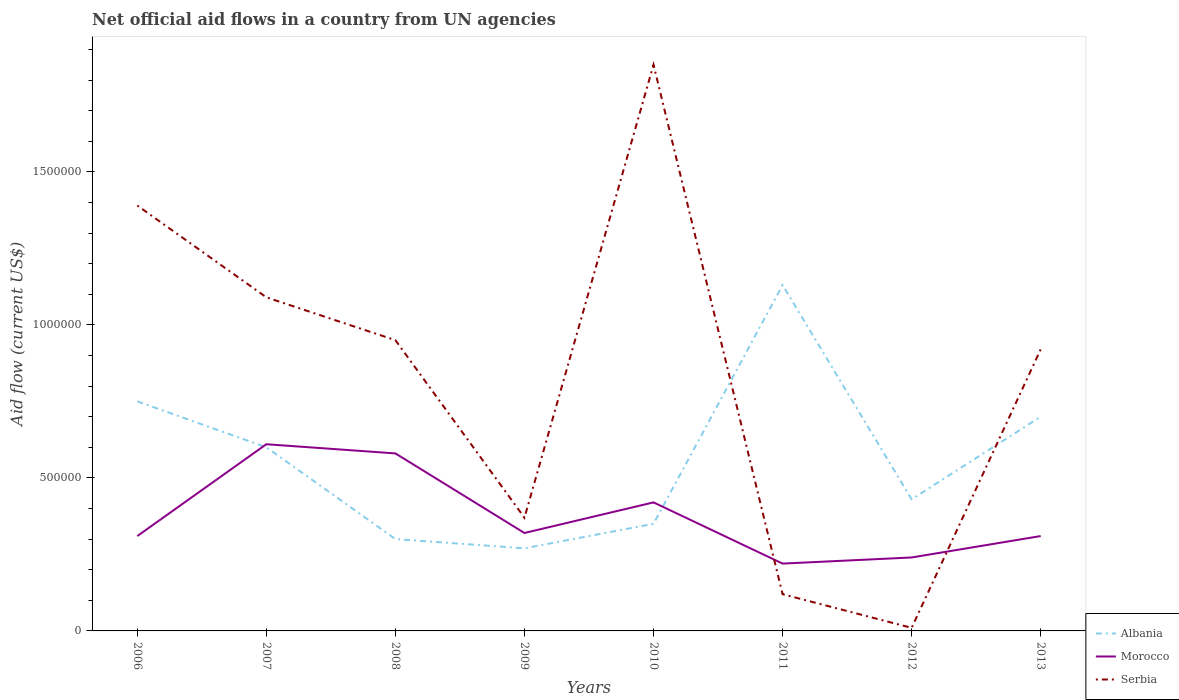How many different coloured lines are there?
Keep it short and to the point. 3. Across all years, what is the maximum net official aid flow in Serbia?
Provide a succinct answer. 10000. In which year was the net official aid flow in Morocco maximum?
Offer a terse response. 2011. What is the total net official aid flow in Albania in the graph?
Give a very brief answer. -4.00e+05. What is the difference between the highest and the second highest net official aid flow in Serbia?
Offer a terse response. 1.84e+06. Are the values on the major ticks of Y-axis written in scientific E-notation?
Provide a succinct answer. No. Does the graph contain any zero values?
Your response must be concise. No. Does the graph contain grids?
Ensure brevity in your answer.  No. How are the legend labels stacked?
Offer a very short reply. Vertical. What is the title of the graph?
Your response must be concise. Net official aid flows in a country from UN agencies. What is the label or title of the X-axis?
Your answer should be compact. Years. What is the Aid flow (current US$) in Albania in 2006?
Offer a very short reply. 7.50e+05. What is the Aid flow (current US$) in Serbia in 2006?
Ensure brevity in your answer.  1.39e+06. What is the Aid flow (current US$) in Serbia in 2007?
Your answer should be very brief. 1.09e+06. What is the Aid flow (current US$) in Morocco in 2008?
Offer a terse response. 5.80e+05. What is the Aid flow (current US$) in Serbia in 2008?
Give a very brief answer. 9.50e+05. What is the Aid flow (current US$) in Morocco in 2009?
Provide a succinct answer. 3.20e+05. What is the Aid flow (current US$) in Serbia in 2009?
Give a very brief answer. 3.70e+05. What is the Aid flow (current US$) in Morocco in 2010?
Offer a terse response. 4.20e+05. What is the Aid flow (current US$) of Serbia in 2010?
Your answer should be very brief. 1.85e+06. What is the Aid flow (current US$) in Albania in 2011?
Offer a terse response. 1.13e+06. What is the Aid flow (current US$) of Morocco in 2011?
Ensure brevity in your answer.  2.20e+05. What is the Aid flow (current US$) of Albania in 2012?
Ensure brevity in your answer.  4.30e+05. What is the Aid flow (current US$) in Morocco in 2012?
Your answer should be very brief. 2.40e+05. What is the Aid flow (current US$) of Morocco in 2013?
Ensure brevity in your answer.  3.10e+05. What is the Aid flow (current US$) of Serbia in 2013?
Keep it short and to the point. 9.20e+05. Across all years, what is the maximum Aid flow (current US$) of Albania?
Your answer should be compact. 1.13e+06. Across all years, what is the maximum Aid flow (current US$) of Morocco?
Keep it short and to the point. 6.10e+05. Across all years, what is the maximum Aid flow (current US$) in Serbia?
Keep it short and to the point. 1.85e+06. Across all years, what is the minimum Aid flow (current US$) in Albania?
Your answer should be compact. 2.70e+05. Across all years, what is the minimum Aid flow (current US$) in Morocco?
Provide a succinct answer. 2.20e+05. Across all years, what is the minimum Aid flow (current US$) in Serbia?
Your answer should be compact. 10000. What is the total Aid flow (current US$) in Albania in the graph?
Your response must be concise. 4.53e+06. What is the total Aid flow (current US$) of Morocco in the graph?
Your response must be concise. 3.01e+06. What is the total Aid flow (current US$) in Serbia in the graph?
Your answer should be compact. 6.70e+06. What is the difference between the Aid flow (current US$) of Serbia in 2006 and that in 2007?
Your answer should be compact. 3.00e+05. What is the difference between the Aid flow (current US$) in Morocco in 2006 and that in 2008?
Offer a very short reply. -2.70e+05. What is the difference between the Aid flow (current US$) of Serbia in 2006 and that in 2008?
Ensure brevity in your answer.  4.40e+05. What is the difference between the Aid flow (current US$) in Serbia in 2006 and that in 2009?
Make the answer very short. 1.02e+06. What is the difference between the Aid flow (current US$) of Albania in 2006 and that in 2010?
Ensure brevity in your answer.  4.00e+05. What is the difference between the Aid flow (current US$) of Morocco in 2006 and that in 2010?
Your answer should be compact. -1.10e+05. What is the difference between the Aid flow (current US$) in Serbia in 2006 and that in 2010?
Your response must be concise. -4.60e+05. What is the difference between the Aid flow (current US$) of Albania in 2006 and that in 2011?
Provide a succinct answer. -3.80e+05. What is the difference between the Aid flow (current US$) of Serbia in 2006 and that in 2011?
Give a very brief answer. 1.27e+06. What is the difference between the Aid flow (current US$) in Serbia in 2006 and that in 2012?
Make the answer very short. 1.38e+06. What is the difference between the Aid flow (current US$) of Morocco in 2006 and that in 2013?
Your response must be concise. 0. What is the difference between the Aid flow (current US$) of Serbia in 2007 and that in 2008?
Offer a very short reply. 1.40e+05. What is the difference between the Aid flow (current US$) of Serbia in 2007 and that in 2009?
Keep it short and to the point. 7.20e+05. What is the difference between the Aid flow (current US$) of Morocco in 2007 and that in 2010?
Give a very brief answer. 1.90e+05. What is the difference between the Aid flow (current US$) in Serbia in 2007 and that in 2010?
Ensure brevity in your answer.  -7.60e+05. What is the difference between the Aid flow (current US$) of Albania in 2007 and that in 2011?
Your response must be concise. -5.30e+05. What is the difference between the Aid flow (current US$) in Morocco in 2007 and that in 2011?
Your answer should be very brief. 3.90e+05. What is the difference between the Aid flow (current US$) in Serbia in 2007 and that in 2011?
Provide a short and direct response. 9.70e+05. What is the difference between the Aid flow (current US$) of Morocco in 2007 and that in 2012?
Your answer should be very brief. 3.70e+05. What is the difference between the Aid flow (current US$) in Serbia in 2007 and that in 2012?
Your response must be concise. 1.08e+06. What is the difference between the Aid flow (current US$) in Albania in 2007 and that in 2013?
Ensure brevity in your answer.  -1.00e+05. What is the difference between the Aid flow (current US$) of Serbia in 2007 and that in 2013?
Offer a terse response. 1.70e+05. What is the difference between the Aid flow (current US$) of Serbia in 2008 and that in 2009?
Your answer should be very brief. 5.80e+05. What is the difference between the Aid flow (current US$) in Morocco in 2008 and that in 2010?
Your response must be concise. 1.60e+05. What is the difference between the Aid flow (current US$) in Serbia in 2008 and that in 2010?
Provide a short and direct response. -9.00e+05. What is the difference between the Aid flow (current US$) in Albania in 2008 and that in 2011?
Provide a succinct answer. -8.30e+05. What is the difference between the Aid flow (current US$) in Serbia in 2008 and that in 2011?
Offer a very short reply. 8.30e+05. What is the difference between the Aid flow (current US$) of Albania in 2008 and that in 2012?
Provide a succinct answer. -1.30e+05. What is the difference between the Aid flow (current US$) in Serbia in 2008 and that in 2012?
Offer a very short reply. 9.40e+05. What is the difference between the Aid flow (current US$) in Albania in 2008 and that in 2013?
Provide a succinct answer. -4.00e+05. What is the difference between the Aid flow (current US$) in Morocco in 2009 and that in 2010?
Provide a short and direct response. -1.00e+05. What is the difference between the Aid flow (current US$) in Serbia in 2009 and that in 2010?
Your answer should be very brief. -1.48e+06. What is the difference between the Aid flow (current US$) in Albania in 2009 and that in 2011?
Ensure brevity in your answer.  -8.60e+05. What is the difference between the Aid flow (current US$) in Albania in 2009 and that in 2012?
Your response must be concise. -1.60e+05. What is the difference between the Aid flow (current US$) of Albania in 2009 and that in 2013?
Ensure brevity in your answer.  -4.30e+05. What is the difference between the Aid flow (current US$) in Morocco in 2009 and that in 2013?
Your answer should be very brief. 10000. What is the difference between the Aid flow (current US$) in Serbia in 2009 and that in 2013?
Offer a very short reply. -5.50e+05. What is the difference between the Aid flow (current US$) in Albania in 2010 and that in 2011?
Make the answer very short. -7.80e+05. What is the difference between the Aid flow (current US$) of Serbia in 2010 and that in 2011?
Provide a short and direct response. 1.73e+06. What is the difference between the Aid flow (current US$) in Albania in 2010 and that in 2012?
Provide a succinct answer. -8.00e+04. What is the difference between the Aid flow (current US$) of Serbia in 2010 and that in 2012?
Ensure brevity in your answer.  1.84e+06. What is the difference between the Aid flow (current US$) in Albania in 2010 and that in 2013?
Offer a terse response. -3.50e+05. What is the difference between the Aid flow (current US$) of Morocco in 2010 and that in 2013?
Make the answer very short. 1.10e+05. What is the difference between the Aid flow (current US$) in Serbia in 2010 and that in 2013?
Your answer should be very brief. 9.30e+05. What is the difference between the Aid flow (current US$) in Albania in 2011 and that in 2013?
Offer a terse response. 4.30e+05. What is the difference between the Aid flow (current US$) in Serbia in 2011 and that in 2013?
Offer a very short reply. -8.00e+05. What is the difference between the Aid flow (current US$) in Albania in 2012 and that in 2013?
Your answer should be very brief. -2.70e+05. What is the difference between the Aid flow (current US$) in Morocco in 2012 and that in 2013?
Offer a very short reply. -7.00e+04. What is the difference between the Aid flow (current US$) in Serbia in 2012 and that in 2013?
Provide a short and direct response. -9.10e+05. What is the difference between the Aid flow (current US$) of Albania in 2006 and the Aid flow (current US$) of Serbia in 2007?
Provide a short and direct response. -3.40e+05. What is the difference between the Aid flow (current US$) of Morocco in 2006 and the Aid flow (current US$) of Serbia in 2007?
Your response must be concise. -7.80e+05. What is the difference between the Aid flow (current US$) of Albania in 2006 and the Aid flow (current US$) of Serbia in 2008?
Your response must be concise. -2.00e+05. What is the difference between the Aid flow (current US$) of Morocco in 2006 and the Aid flow (current US$) of Serbia in 2008?
Make the answer very short. -6.40e+05. What is the difference between the Aid flow (current US$) of Albania in 2006 and the Aid flow (current US$) of Morocco in 2010?
Give a very brief answer. 3.30e+05. What is the difference between the Aid flow (current US$) in Albania in 2006 and the Aid flow (current US$) in Serbia in 2010?
Keep it short and to the point. -1.10e+06. What is the difference between the Aid flow (current US$) in Morocco in 2006 and the Aid flow (current US$) in Serbia in 2010?
Your response must be concise. -1.54e+06. What is the difference between the Aid flow (current US$) in Albania in 2006 and the Aid flow (current US$) in Morocco in 2011?
Your response must be concise. 5.30e+05. What is the difference between the Aid flow (current US$) of Albania in 2006 and the Aid flow (current US$) of Serbia in 2011?
Give a very brief answer. 6.30e+05. What is the difference between the Aid flow (current US$) of Albania in 2006 and the Aid flow (current US$) of Morocco in 2012?
Offer a terse response. 5.10e+05. What is the difference between the Aid flow (current US$) in Albania in 2006 and the Aid flow (current US$) in Serbia in 2012?
Your answer should be compact. 7.40e+05. What is the difference between the Aid flow (current US$) of Albania in 2006 and the Aid flow (current US$) of Serbia in 2013?
Your response must be concise. -1.70e+05. What is the difference between the Aid flow (current US$) of Morocco in 2006 and the Aid flow (current US$) of Serbia in 2013?
Keep it short and to the point. -6.10e+05. What is the difference between the Aid flow (current US$) of Albania in 2007 and the Aid flow (current US$) of Morocco in 2008?
Offer a very short reply. 2.00e+04. What is the difference between the Aid flow (current US$) of Albania in 2007 and the Aid flow (current US$) of Serbia in 2008?
Make the answer very short. -3.50e+05. What is the difference between the Aid flow (current US$) in Albania in 2007 and the Aid flow (current US$) in Morocco in 2009?
Your answer should be very brief. 2.80e+05. What is the difference between the Aid flow (current US$) of Albania in 2007 and the Aid flow (current US$) of Serbia in 2010?
Your response must be concise. -1.25e+06. What is the difference between the Aid flow (current US$) in Morocco in 2007 and the Aid flow (current US$) in Serbia in 2010?
Offer a very short reply. -1.24e+06. What is the difference between the Aid flow (current US$) in Albania in 2007 and the Aid flow (current US$) in Morocco in 2011?
Offer a very short reply. 3.80e+05. What is the difference between the Aid flow (current US$) of Albania in 2007 and the Aid flow (current US$) of Serbia in 2012?
Provide a succinct answer. 5.90e+05. What is the difference between the Aid flow (current US$) of Morocco in 2007 and the Aid flow (current US$) of Serbia in 2012?
Provide a succinct answer. 6.00e+05. What is the difference between the Aid flow (current US$) of Albania in 2007 and the Aid flow (current US$) of Serbia in 2013?
Provide a short and direct response. -3.20e+05. What is the difference between the Aid flow (current US$) of Morocco in 2007 and the Aid flow (current US$) of Serbia in 2013?
Offer a terse response. -3.10e+05. What is the difference between the Aid flow (current US$) in Albania in 2008 and the Aid flow (current US$) in Morocco in 2009?
Your answer should be compact. -2.00e+04. What is the difference between the Aid flow (current US$) in Albania in 2008 and the Aid flow (current US$) in Serbia in 2009?
Your response must be concise. -7.00e+04. What is the difference between the Aid flow (current US$) in Albania in 2008 and the Aid flow (current US$) in Morocco in 2010?
Make the answer very short. -1.20e+05. What is the difference between the Aid flow (current US$) of Albania in 2008 and the Aid flow (current US$) of Serbia in 2010?
Your answer should be very brief. -1.55e+06. What is the difference between the Aid flow (current US$) of Morocco in 2008 and the Aid flow (current US$) of Serbia in 2010?
Make the answer very short. -1.27e+06. What is the difference between the Aid flow (current US$) of Morocco in 2008 and the Aid flow (current US$) of Serbia in 2011?
Your response must be concise. 4.60e+05. What is the difference between the Aid flow (current US$) of Albania in 2008 and the Aid flow (current US$) of Morocco in 2012?
Provide a short and direct response. 6.00e+04. What is the difference between the Aid flow (current US$) of Albania in 2008 and the Aid flow (current US$) of Serbia in 2012?
Offer a terse response. 2.90e+05. What is the difference between the Aid flow (current US$) of Morocco in 2008 and the Aid flow (current US$) of Serbia in 2012?
Provide a succinct answer. 5.70e+05. What is the difference between the Aid flow (current US$) in Albania in 2008 and the Aid flow (current US$) in Serbia in 2013?
Give a very brief answer. -6.20e+05. What is the difference between the Aid flow (current US$) in Albania in 2009 and the Aid flow (current US$) in Serbia in 2010?
Your response must be concise. -1.58e+06. What is the difference between the Aid flow (current US$) of Morocco in 2009 and the Aid flow (current US$) of Serbia in 2010?
Offer a very short reply. -1.53e+06. What is the difference between the Aid flow (current US$) of Albania in 2009 and the Aid flow (current US$) of Serbia in 2011?
Provide a succinct answer. 1.50e+05. What is the difference between the Aid flow (current US$) in Morocco in 2009 and the Aid flow (current US$) in Serbia in 2011?
Your answer should be very brief. 2.00e+05. What is the difference between the Aid flow (current US$) of Morocco in 2009 and the Aid flow (current US$) of Serbia in 2012?
Your answer should be very brief. 3.10e+05. What is the difference between the Aid flow (current US$) in Albania in 2009 and the Aid flow (current US$) in Serbia in 2013?
Ensure brevity in your answer.  -6.50e+05. What is the difference between the Aid flow (current US$) in Morocco in 2009 and the Aid flow (current US$) in Serbia in 2013?
Keep it short and to the point. -6.00e+05. What is the difference between the Aid flow (current US$) in Albania in 2010 and the Aid flow (current US$) in Morocco in 2011?
Give a very brief answer. 1.30e+05. What is the difference between the Aid flow (current US$) in Albania in 2010 and the Aid flow (current US$) in Serbia in 2011?
Ensure brevity in your answer.  2.30e+05. What is the difference between the Aid flow (current US$) in Albania in 2010 and the Aid flow (current US$) in Morocco in 2012?
Your answer should be very brief. 1.10e+05. What is the difference between the Aid flow (current US$) of Albania in 2010 and the Aid flow (current US$) of Morocco in 2013?
Your answer should be very brief. 4.00e+04. What is the difference between the Aid flow (current US$) in Albania in 2010 and the Aid flow (current US$) in Serbia in 2013?
Keep it short and to the point. -5.70e+05. What is the difference between the Aid flow (current US$) in Morocco in 2010 and the Aid flow (current US$) in Serbia in 2013?
Give a very brief answer. -5.00e+05. What is the difference between the Aid flow (current US$) of Albania in 2011 and the Aid flow (current US$) of Morocco in 2012?
Offer a terse response. 8.90e+05. What is the difference between the Aid flow (current US$) of Albania in 2011 and the Aid flow (current US$) of Serbia in 2012?
Offer a very short reply. 1.12e+06. What is the difference between the Aid flow (current US$) in Albania in 2011 and the Aid flow (current US$) in Morocco in 2013?
Keep it short and to the point. 8.20e+05. What is the difference between the Aid flow (current US$) of Albania in 2011 and the Aid flow (current US$) of Serbia in 2013?
Your answer should be very brief. 2.10e+05. What is the difference between the Aid flow (current US$) of Morocco in 2011 and the Aid flow (current US$) of Serbia in 2013?
Offer a very short reply. -7.00e+05. What is the difference between the Aid flow (current US$) of Albania in 2012 and the Aid flow (current US$) of Serbia in 2013?
Keep it short and to the point. -4.90e+05. What is the difference between the Aid flow (current US$) of Morocco in 2012 and the Aid flow (current US$) of Serbia in 2013?
Keep it short and to the point. -6.80e+05. What is the average Aid flow (current US$) of Albania per year?
Provide a succinct answer. 5.66e+05. What is the average Aid flow (current US$) in Morocco per year?
Your answer should be very brief. 3.76e+05. What is the average Aid flow (current US$) in Serbia per year?
Provide a short and direct response. 8.38e+05. In the year 2006, what is the difference between the Aid flow (current US$) in Albania and Aid flow (current US$) in Serbia?
Make the answer very short. -6.40e+05. In the year 2006, what is the difference between the Aid flow (current US$) of Morocco and Aid flow (current US$) of Serbia?
Provide a succinct answer. -1.08e+06. In the year 2007, what is the difference between the Aid flow (current US$) in Albania and Aid flow (current US$) in Morocco?
Ensure brevity in your answer.  -10000. In the year 2007, what is the difference between the Aid flow (current US$) of Albania and Aid flow (current US$) of Serbia?
Make the answer very short. -4.90e+05. In the year 2007, what is the difference between the Aid flow (current US$) of Morocco and Aid flow (current US$) of Serbia?
Make the answer very short. -4.80e+05. In the year 2008, what is the difference between the Aid flow (current US$) of Albania and Aid flow (current US$) of Morocco?
Offer a terse response. -2.80e+05. In the year 2008, what is the difference between the Aid flow (current US$) of Albania and Aid flow (current US$) of Serbia?
Your answer should be very brief. -6.50e+05. In the year 2008, what is the difference between the Aid flow (current US$) in Morocco and Aid flow (current US$) in Serbia?
Your response must be concise. -3.70e+05. In the year 2009, what is the difference between the Aid flow (current US$) in Albania and Aid flow (current US$) in Serbia?
Offer a terse response. -1.00e+05. In the year 2009, what is the difference between the Aid flow (current US$) in Morocco and Aid flow (current US$) in Serbia?
Keep it short and to the point. -5.00e+04. In the year 2010, what is the difference between the Aid flow (current US$) of Albania and Aid flow (current US$) of Morocco?
Your response must be concise. -7.00e+04. In the year 2010, what is the difference between the Aid flow (current US$) of Albania and Aid flow (current US$) of Serbia?
Offer a very short reply. -1.50e+06. In the year 2010, what is the difference between the Aid flow (current US$) of Morocco and Aid flow (current US$) of Serbia?
Your response must be concise. -1.43e+06. In the year 2011, what is the difference between the Aid flow (current US$) of Albania and Aid flow (current US$) of Morocco?
Offer a terse response. 9.10e+05. In the year 2011, what is the difference between the Aid flow (current US$) in Albania and Aid flow (current US$) in Serbia?
Give a very brief answer. 1.01e+06. In the year 2012, what is the difference between the Aid flow (current US$) in Albania and Aid flow (current US$) in Morocco?
Your answer should be compact. 1.90e+05. In the year 2012, what is the difference between the Aid flow (current US$) of Albania and Aid flow (current US$) of Serbia?
Give a very brief answer. 4.20e+05. In the year 2013, what is the difference between the Aid flow (current US$) in Albania and Aid flow (current US$) in Serbia?
Provide a short and direct response. -2.20e+05. In the year 2013, what is the difference between the Aid flow (current US$) of Morocco and Aid flow (current US$) of Serbia?
Give a very brief answer. -6.10e+05. What is the ratio of the Aid flow (current US$) in Morocco in 2006 to that in 2007?
Offer a terse response. 0.51. What is the ratio of the Aid flow (current US$) in Serbia in 2006 to that in 2007?
Ensure brevity in your answer.  1.28. What is the ratio of the Aid flow (current US$) of Albania in 2006 to that in 2008?
Provide a short and direct response. 2.5. What is the ratio of the Aid flow (current US$) of Morocco in 2006 to that in 2008?
Ensure brevity in your answer.  0.53. What is the ratio of the Aid flow (current US$) of Serbia in 2006 to that in 2008?
Provide a succinct answer. 1.46. What is the ratio of the Aid flow (current US$) in Albania in 2006 to that in 2009?
Give a very brief answer. 2.78. What is the ratio of the Aid flow (current US$) of Morocco in 2006 to that in 2009?
Offer a terse response. 0.97. What is the ratio of the Aid flow (current US$) in Serbia in 2006 to that in 2009?
Your answer should be very brief. 3.76. What is the ratio of the Aid flow (current US$) of Albania in 2006 to that in 2010?
Give a very brief answer. 2.14. What is the ratio of the Aid flow (current US$) in Morocco in 2006 to that in 2010?
Give a very brief answer. 0.74. What is the ratio of the Aid flow (current US$) of Serbia in 2006 to that in 2010?
Ensure brevity in your answer.  0.75. What is the ratio of the Aid flow (current US$) in Albania in 2006 to that in 2011?
Provide a succinct answer. 0.66. What is the ratio of the Aid flow (current US$) of Morocco in 2006 to that in 2011?
Offer a very short reply. 1.41. What is the ratio of the Aid flow (current US$) of Serbia in 2006 to that in 2011?
Make the answer very short. 11.58. What is the ratio of the Aid flow (current US$) of Albania in 2006 to that in 2012?
Give a very brief answer. 1.74. What is the ratio of the Aid flow (current US$) of Morocco in 2006 to that in 2012?
Your response must be concise. 1.29. What is the ratio of the Aid flow (current US$) of Serbia in 2006 to that in 2012?
Provide a succinct answer. 139. What is the ratio of the Aid flow (current US$) in Albania in 2006 to that in 2013?
Your answer should be very brief. 1.07. What is the ratio of the Aid flow (current US$) in Morocco in 2006 to that in 2013?
Make the answer very short. 1. What is the ratio of the Aid flow (current US$) in Serbia in 2006 to that in 2013?
Give a very brief answer. 1.51. What is the ratio of the Aid flow (current US$) of Albania in 2007 to that in 2008?
Offer a terse response. 2. What is the ratio of the Aid flow (current US$) in Morocco in 2007 to that in 2008?
Your answer should be very brief. 1.05. What is the ratio of the Aid flow (current US$) of Serbia in 2007 to that in 2008?
Your answer should be very brief. 1.15. What is the ratio of the Aid flow (current US$) in Albania in 2007 to that in 2009?
Keep it short and to the point. 2.22. What is the ratio of the Aid flow (current US$) of Morocco in 2007 to that in 2009?
Offer a terse response. 1.91. What is the ratio of the Aid flow (current US$) of Serbia in 2007 to that in 2009?
Offer a terse response. 2.95. What is the ratio of the Aid flow (current US$) in Albania in 2007 to that in 2010?
Your answer should be compact. 1.71. What is the ratio of the Aid flow (current US$) of Morocco in 2007 to that in 2010?
Offer a very short reply. 1.45. What is the ratio of the Aid flow (current US$) in Serbia in 2007 to that in 2010?
Keep it short and to the point. 0.59. What is the ratio of the Aid flow (current US$) in Albania in 2007 to that in 2011?
Offer a very short reply. 0.53. What is the ratio of the Aid flow (current US$) in Morocco in 2007 to that in 2011?
Offer a very short reply. 2.77. What is the ratio of the Aid flow (current US$) in Serbia in 2007 to that in 2011?
Ensure brevity in your answer.  9.08. What is the ratio of the Aid flow (current US$) in Albania in 2007 to that in 2012?
Your answer should be very brief. 1.4. What is the ratio of the Aid flow (current US$) in Morocco in 2007 to that in 2012?
Provide a short and direct response. 2.54. What is the ratio of the Aid flow (current US$) of Serbia in 2007 to that in 2012?
Provide a short and direct response. 109. What is the ratio of the Aid flow (current US$) of Albania in 2007 to that in 2013?
Your answer should be compact. 0.86. What is the ratio of the Aid flow (current US$) of Morocco in 2007 to that in 2013?
Keep it short and to the point. 1.97. What is the ratio of the Aid flow (current US$) of Serbia in 2007 to that in 2013?
Provide a succinct answer. 1.18. What is the ratio of the Aid flow (current US$) in Albania in 2008 to that in 2009?
Keep it short and to the point. 1.11. What is the ratio of the Aid flow (current US$) of Morocco in 2008 to that in 2009?
Provide a succinct answer. 1.81. What is the ratio of the Aid flow (current US$) in Serbia in 2008 to that in 2009?
Offer a very short reply. 2.57. What is the ratio of the Aid flow (current US$) in Morocco in 2008 to that in 2010?
Ensure brevity in your answer.  1.38. What is the ratio of the Aid flow (current US$) of Serbia in 2008 to that in 2010?
Provide a short and direct response. 0.51. What is the ratio of the Aid flow (current US$) of Albania in 2008 to that in 2011?
Keep it short and to the point. 0.27. What is the ratio of the Aid flow (current US$) in Morocco in 2008 to that in 2011?
Provide a succinct answer. 2.64. What is the ratio of the Aid flow (current US$) in Serbia in 2008 to that in 2011?
Your response must be concise. 7.92. What is the ratio of the Aid flow (current US$) in Albania in 2008 to that in 2012?
Offer a very short reply. 0.7. What is the ratio of the Aid flow (current US$) of Morocco in 2008 to that in 2012?
Your answer should be very brief. 2.42. What is the ratio of the Aid flow (current US$) in Serbia in 2008 to that in 2012?
Keep it short and to the point. 95. What is the ratio of the Aid flow (current US$) of Albania in 2008 to that in 2013?
Provide a short and direct response. 0.43. What is the ratio of the Aid flow (current US$) in Morocco in 2008 to that in 2013?
Ensure brevity in your answer.  1.87. What is the ratio of the Aid flow (current US$) in Serbia in 2008 to that in 2013?
Ensure brevity in your answer.  1.03. What is the ratio of the Aid flow (current US$) in Albania in 2009 to that in 2010?
Offer a very short reply. 0.77. What is the ratio of the Aid flow (current US$) in Morocco in 2009 to that in 2010?
Give a very brief answer. 0.76. What is the ratio of the Aid flow (current US$) of Serbia in 2009 to that in 2010?
Your answer should be very brief. 0.2. What is the ratio of the Aid flow (current US$) in Albania in 2009 to that in 2011?
Your answer should be very brief. 0.24. What is the ratio of the Aid flow (current US$) in Morocco in 2009 to that in 2011?
Ensure brevity in your answer.  1.45. What is the ratio of the Aid flow (current US$) of Serbia in 2009 to that in 2011?
Your response must be concise. 3.08. What is the ratio of the Aid flow (current US$) in Albania in 2009 to that in 2012?
Offer a terse response. 0.63. What is the ratio of the Aid flow (current US$) in Serbia in 2009 to that in 2012?
Make the answer very short. 37. What is the ratio of the Aid flow (current US$) in Albania in 2009 to that in 2013?
Ensure brevity in your answer.  0.39. What is the ratio of the Aid flow (current US$) in Morocco in 2009 to that in 2013?
Ensure brevity in your answer.  1.03. What is the ratio of the Aid flow (current US$) in Serbia in 2009 to that in 2013?
Your response must be concise. 0.4. What is the ratio of the Aid flow (current US$) of Albania in 2010 to that in 2011?
Offer a terse response. 0.31. What is the ratio of the Aid flow (current US$) of Morocco in 2010 to that in 2011?
Make the answer very short. 1.91. What is the ratio of the Aid flow (current US$) in Serbia in 2010 to that in 2011?
Make the answer very short. 15.42. What is the ratio of the Aid flow (current US$) of Albania in 2010 to that in 2012?
Ensure brevity in your answer.  0.81. What is the ratio of the Aid flow (current US$) of Morocco in 2010 to that in 2012?
Keep it short and to the point. 1.75. What is the ratio of the Aid flow (current US$) of Serbia in 2010 to that in 2012?
Provide a succinct answer. 185. What is the ratio of the Aid flow (current US$) in Albania in 2010 to that in 2013?
Give a very brief answer. 0.5. What is the ratio of the Aid flow (current US$) of Morocco in 2010 to that in 2013?
Ensure brevity in your answer.  1.35. What is the ratio of the Aid flow (current US$) in Serbia in 2010 to that in 2013?
Offer a terse response. 2.01. What is the ratio of the Aid flow (current US$) in Albania in 2011 to that in 2012?
Provide a short and direct response. 2.63. What is the ratio of the Aid flow (current US$) in Albania in 2011 to that in 2013?
Your answer should be compact. 1.61. What is the ratio of the Aid flow (current US$) of Morocco in 2011 to that in 2013?
Ensure brevity in your answer.  0.71. What is the ratio of the Aid flow (current US$) in Serbia in 2011 to that in 2013?
Your answer should be very brief. 0.13. What is the ratio of the Aid flow (current US$) in Albania in 2012 to that in 2013?
Your answer should be very brief. 0.61. What is the ratio of the Aid flow (current US$) of Morocco in 2012 to that in 2013?
Give a very brief answer. 0.77. What is the ratio of the Aid flow (current US$) in Serbia in 2012 to that in 2013?
Give a very brief answer. 0.01. What is the difference between the highest and the second highest Aid flow (current US$) of Albania?
Offer a terse response. 3.80e+05. What is the difference between the highest and the second highest Aid flow (current US$) in Serbia?
Offer a very short reply. 4.60e+05. What is the difference between the highest and the lowest Aid flow (current US$) of Albania?
Your answer should be very brief. 8.60e+05. What is the difference between the highest and the lowest Aid flow (current US$) in Serbia?
Give a very brief answer. 1.84e+06. 